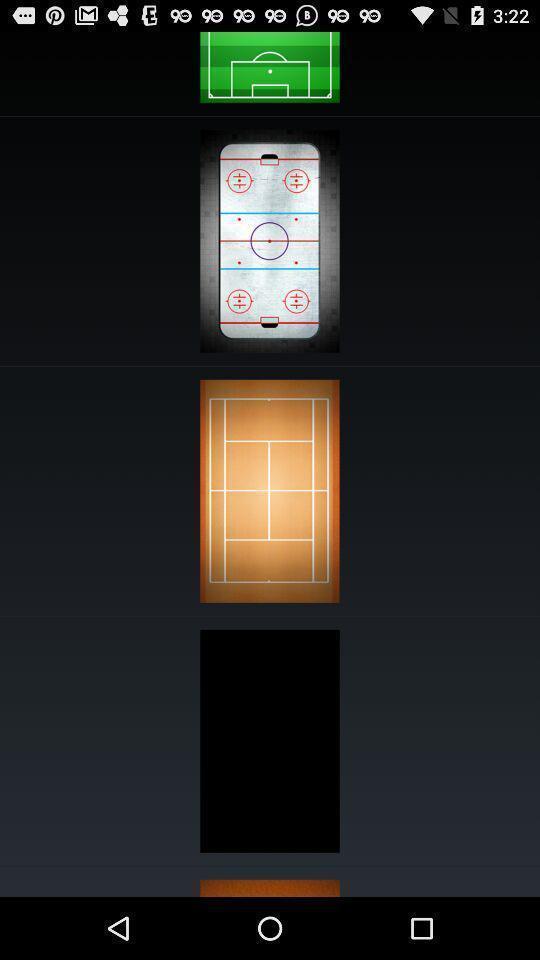Explain what's happening in this screen capture. Page displaying view of various outdoor courts. 